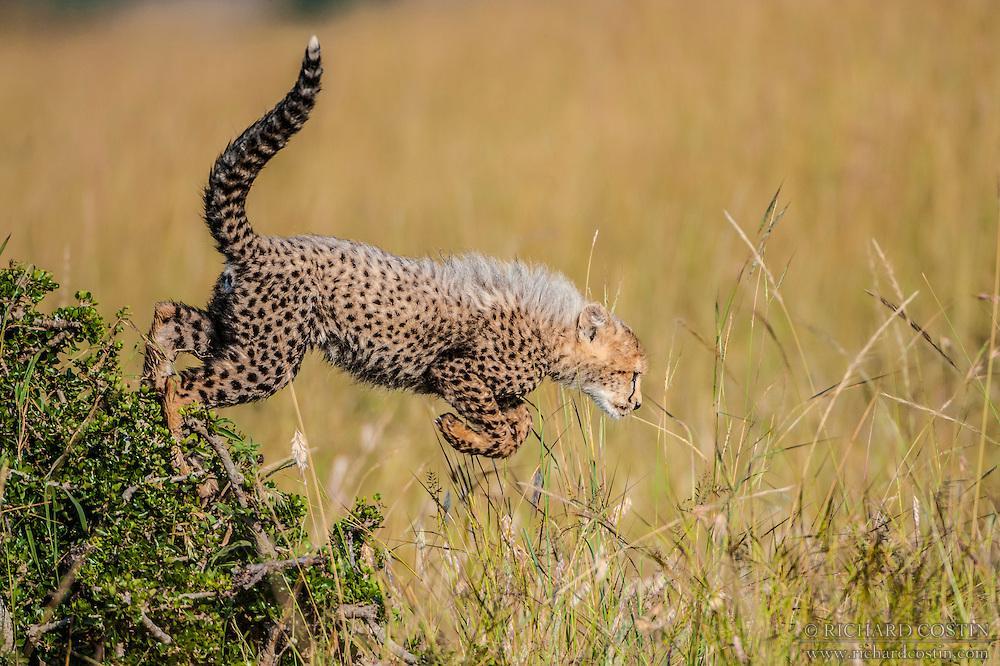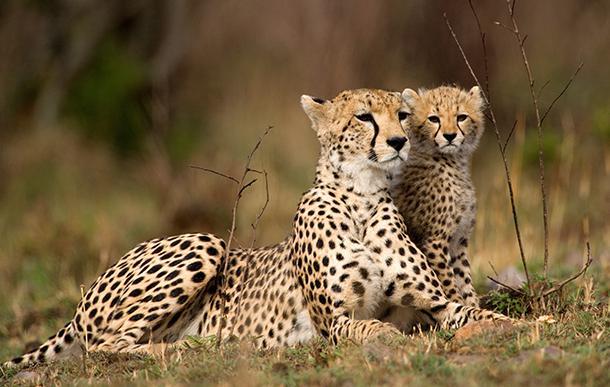The first image is the image on the left, the second image is the image on the right. Analyze the images presented: Is the assertion "Cheeta cubs are playing with moms tail" valid? Answer yes or no. No. The first image is the image on the left, the second image is the image on the right. Examine the images to the left and right. Is the description "There is one cheetah in the left image and two cheetahs in the right image" accurate? Answer yes or no. Yes. 